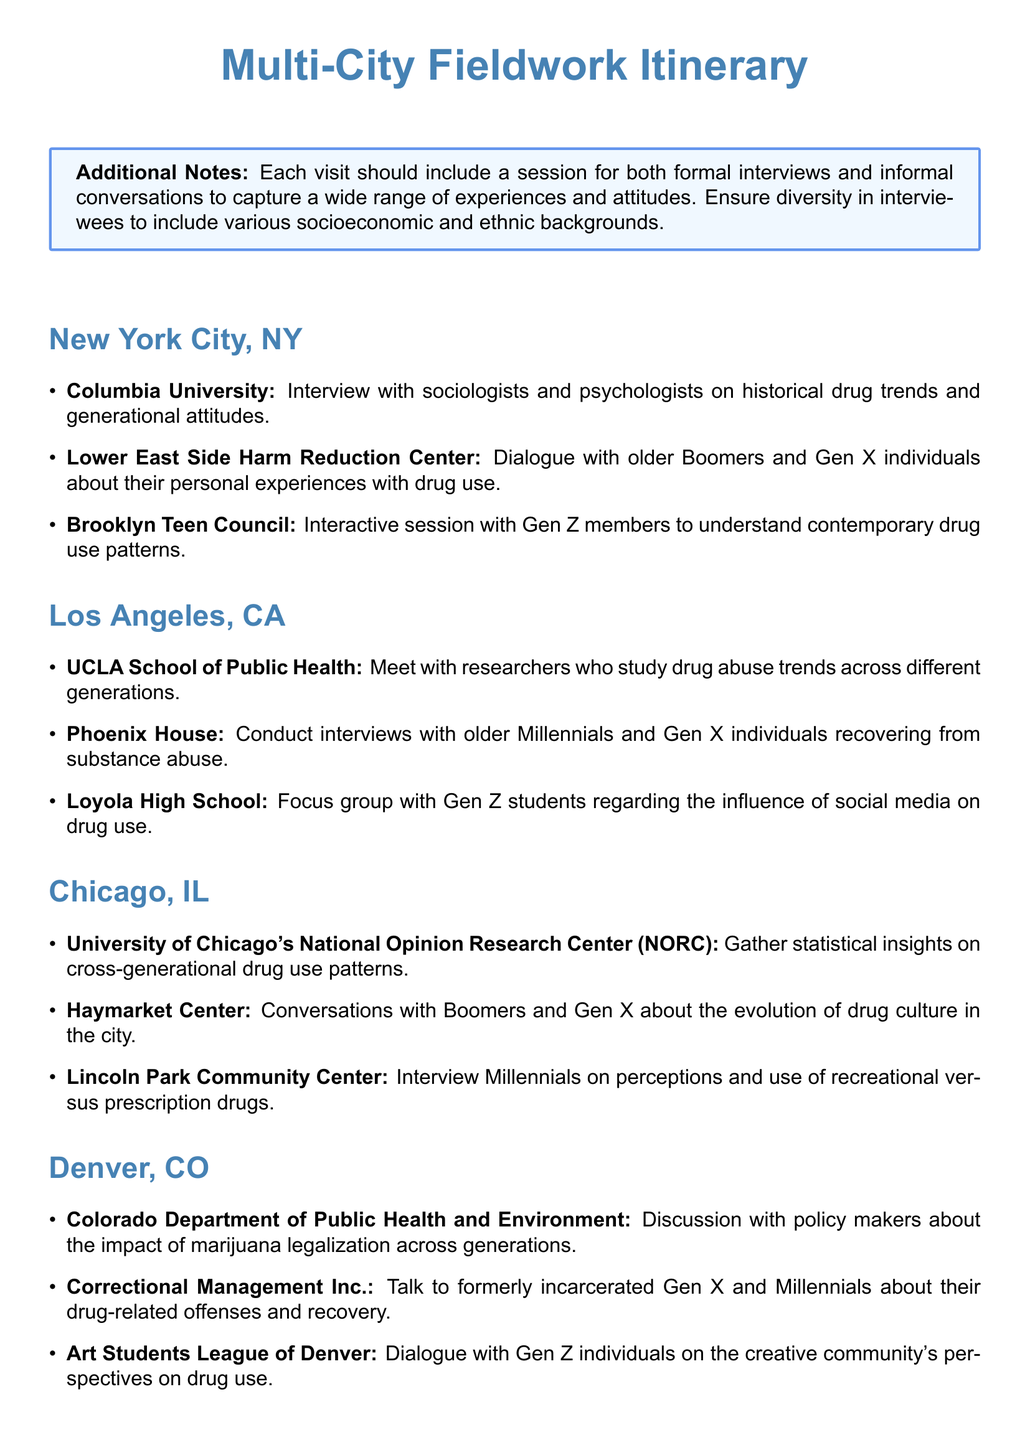What is the first city listed in the itinerary? The itinerary begins with New York City, NY as the first location for fieldwork activities.
Answer: New York City, NY How many locations are planned for interviews in Denver, CO? There are three specified venues in Denver, CO for conducting interviews and discussions.
Answer: 3 Which group is interviewed at the Lower East Side Harm Reduction Center? The document specifies that older Boomers and Gen X individuals will share their personal experiences with drug use here.
Answer: Older Boomers and Gen X What is the focus of the interviews at UCLA School of Public Health? The interviews will center on drug abuse trends studied across different generations, making it a research-focused visit.
Answer: Drug abuse trends How is the age group of Gen Z incorporated in the itinerary? Gen Z is included in various activities, specifically in a focus group and conversations at suitable venues like the Brooklyn Teen Council and Loyola High School.
Answer: Focus group and dialogues What organization is associated with the discussion on marijuana legalization? The Colorado Department of Public Health and Environment is listed as the venue for discussing the impact of marijuana legalization across generations.
Answer: Colorado Department of Public Health and Environment Which demographic is being interviewed at the Phoenix House? The document indicates that older Millennials and Gen X individuals attending recovery services will be the interviewees at this location.
Answer: Older Millennials and Gen X What kind of insights will be gathered at the University of Chicago's NORC? The National Opinion Research Center at the University of Chicago will provide statistical insights regarding drug use patterns across generations.
Answer: Statistical insights What is emphasized in the additional notes section? The additional notes stress the importance of including diversity in interviewees regarding socioeconomic and ethnic backgrounds to capture a comprehensive range of experiences.
Answer: Diversity in interviewees 